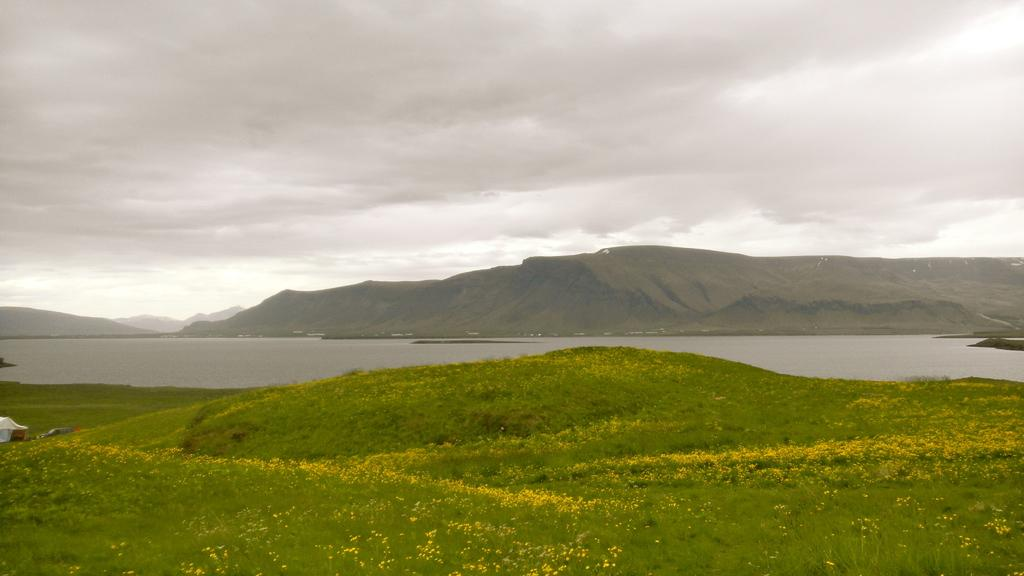What type of plants are present in the image? There are plants with flowers in the image. What can be seen in the background of the image? Water, mountains, and a cloudy sky are visible in the background of the image. Can you see any goldfish swimming in the water in the image? There are no goldfish visible in the image; only plants, flowers, water, mountains, and a cloudy sky can be seen. 